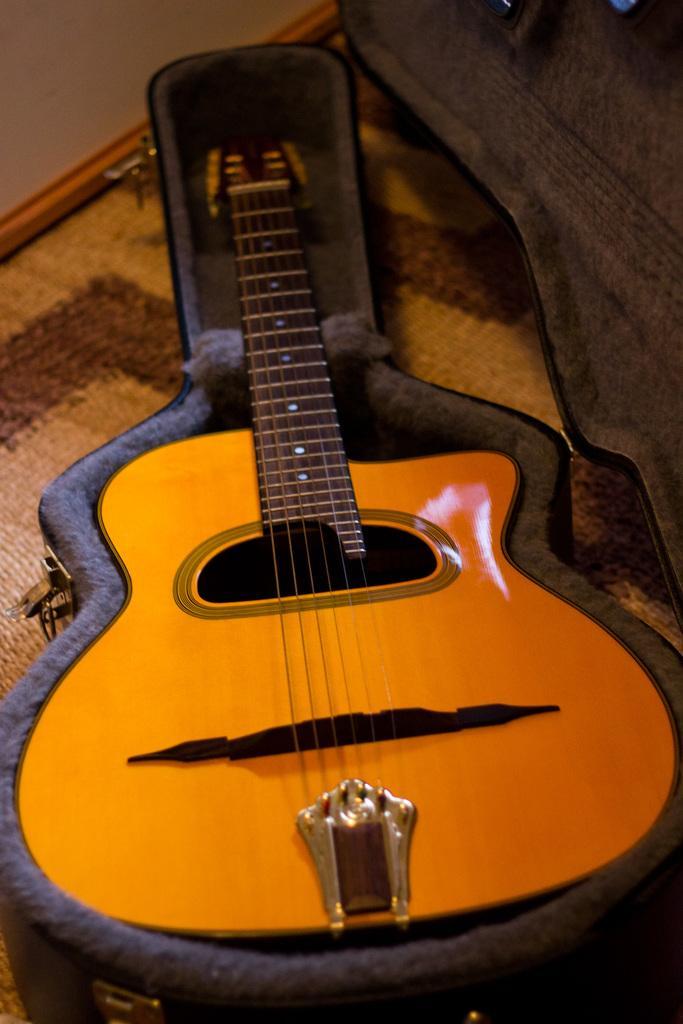Could you give a brief overview of what you see in this image? In this picture, the floor is covered with mat on the mat there is a guitar box in the box there is a wooden guitar with strings. Behind the guitar there are some items. 